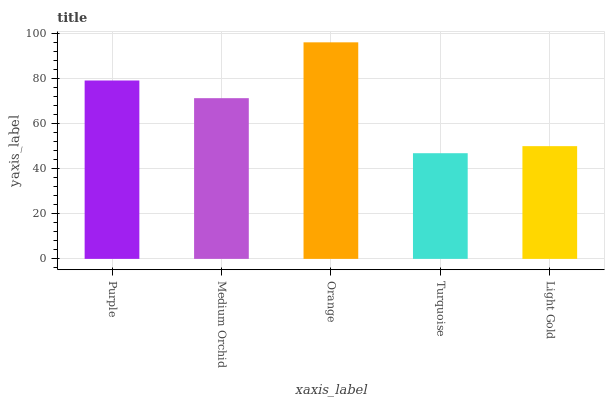Is Turquoise the minimum?
Answer yes or no. Yes. Is Orange the maximum?
Answer yes or no. Yes. Is Medium Orchid the minimum?
Answer yes or no. No. Is Medium Orchid the maximum?
Answer yes or no. No. Is Purple greater than Medium Orchid?
Answer yes or no. Yes. Is Medium Orchid less than Purple?
Answer yes or no. Yes. Is Medium Orchid greater than Purple?
Answer yes or no. No. Is Purple less than Medium Orchid?
Answer yes or no. No. Is Medium Orchid the high median?
Answer yes or no. Yes. Is Medium Orchid the low median?
Answer yes or no. Yes. Is Orange the high median?
Answer yes or no. No. Is Light Gold the low median?
Answer yes or no. No. 